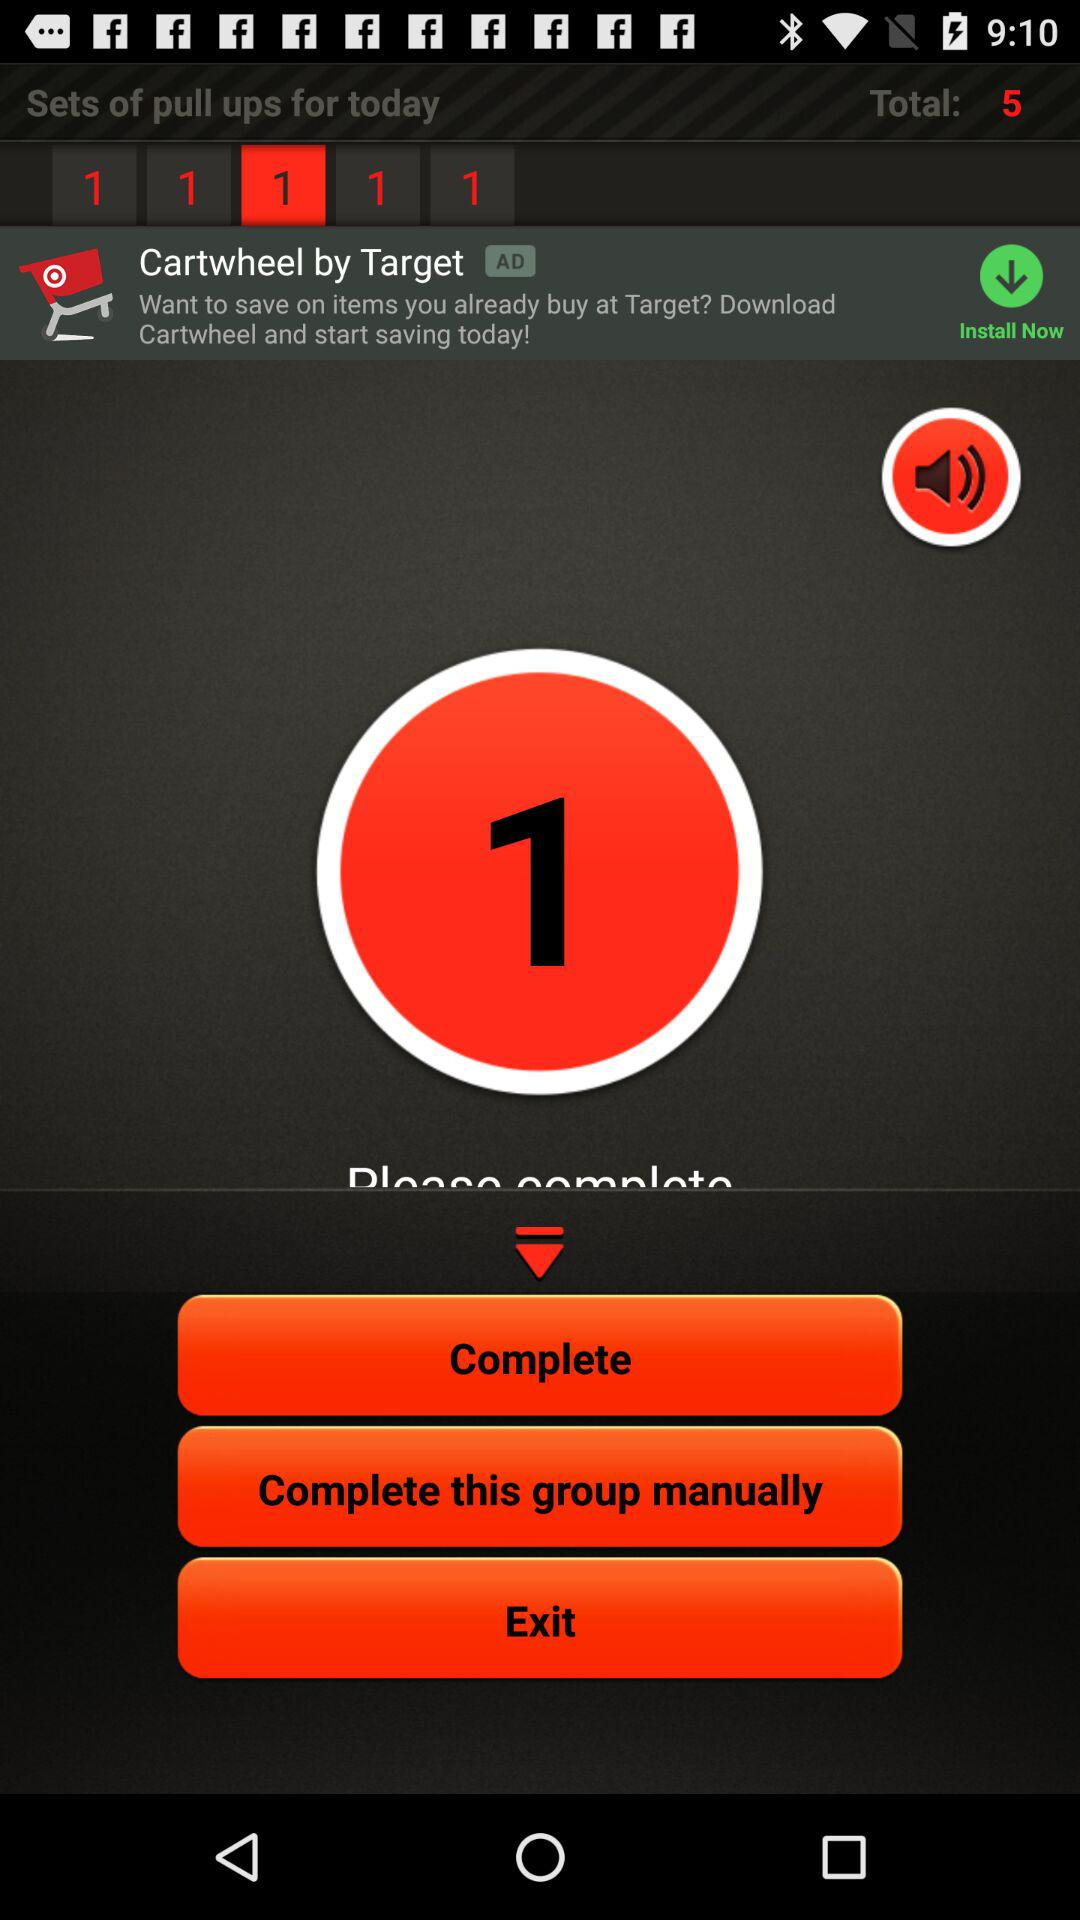How many sets of pull ups are there in total?
Answer the question using a single word or phrase. 5 